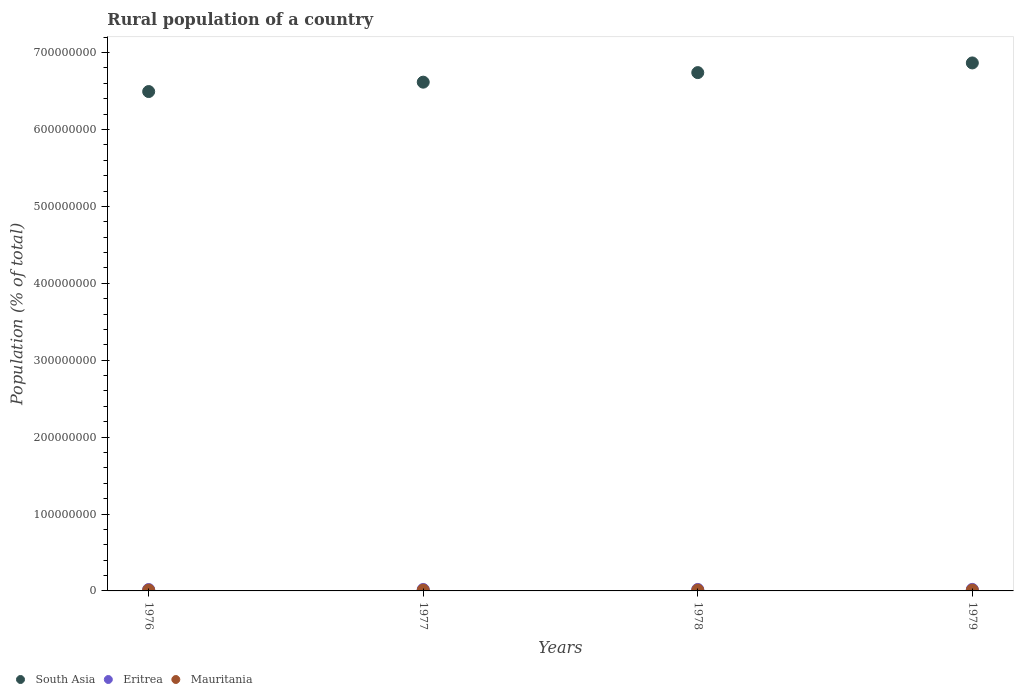How many different coloured dotlines are there?
Offer a terse response. 3. Is the number of dotlines equal to the number of legend labels?
Offer a terse response. Yes. What is the rural population in South Asia in 1976?
Your response must be concise. 6.49e+08. Across all years, what is the maximum rural population in Mauritania?
Give a very brief answer. 1.10e+06. Across all years, what is the minimum rural population in South Asia?
Your answer should be very brief. 6.49e+08. In which year was the rural population in Eritrea maximum?
Your answer should be compact. 1979. In which year was the rural population in Mauritania minimum?
Give a very brief answer. 1976. What is the total rural population in Eritrea in the graph?
Your answer should be compact. 7.65e+06. What is the difference between the rural population in South Asia in 1976 and that in 1978?
Ensure brevity in your answer.  -2.46e+07. What is the difference between the rural population in Mauritania in 1979 and the rural population in Eritrea in 1976?
Keep it short and to the point. -7.35e+05. What is the average rural population in Mauritania per year?
Give a very brief answer. 1.09e+06. In the year 1979, what is the difference between the rural population in Mauritania and rural population in South Asia?
Your response must be concise. -6.85e+08. What is the ratio of the rural population in South Asia in 1976 to that in 1978?
Give a very brief answer. 0.96. Is the difference between the rural population in Mauritania in 1976 and 1977 greater than the difference between the rural population in South Asia in 1976 and 1977?
Give a very brief answer. Yes. What is the difference between the highest and the second highest rural population in South Asia?
Provide a succinct answer. 1.26e+07. What is the difference between the highest and the lowest rural population in Mauritania?
Keep it short and to the point. 3.64e+04. Is the sum of the rural population in Eritrea in 1977 and 1979 greater than the maximum rural population in Mauritania across all years?
Your response must be concise. Yes. Is it the case that in every year, the sum of the rural population in Eritrea and rural population in South Asia  is greater than the rural population in Mauritania?
Offer a very short reply. Yes. Does the rural population in Eritrea monotonically increase over the years?
Provide a succinct answer. Yes. Is the rural population in Mauritania strictly less than the rural population in Eritrea over the years?
Ensure brevity in your answer.  Yes. How many dotlines are there?
Provide a succinct answer. 3. Are the values on the major ticks of Y-axis written in scientific E-notation?
Give a very brief answer. No. Where does the legend appear in the graph?
Your answer should be compact. Bottom left. How many legend labels are there?
Make the answer very short. 3. How are the legend labels stacked?
Your answer should be very brief. Horizontal. What is the title of the graph?
Make the answer very short. Rural population of a country. What is the label or title of the Y-axis?
Provide a succinct answer. Population (% of total). What is the Population (% of total) of South Asia in 1976?
Your response must be concise. 6.49e+08. What is the Population (% of total) of Eritrea in 1976?
Ensure brevity in your answer.  1.84e+06. What is the Population (% of total) in Mauritania in 1976?
Provide a succinct answer. 1.07e+06. What is the Population (% of total) in South Asia in 1977?
Give a very brief answer. 6.62e+08. What is the Population (% of total) in Eritrea in 1977?
Your answer should be compact. 1.89e+06. What is the Population (% of total) of Mauritania in 1977?
Give a very brief answer. 1.08e+06. What is the Population (% of total) of South Asia in 1978?
Keep it short and to the point. 6.74e+08. What is the Population (% of total) in Eritrea in 1978?
Make the answer very short. 1.94e+06. What is the Population (% of total) of Mauritania in 1978?
Your response must be concise. 1.09e+06. What is the Population (% of total) of South Asia in 1979?
Make the answer very short. 6.87e+08. What is the Population (% of total) of Eritrea in 1979?
Ensure brevity in your answer.  1.99e+06. What is the Population (% of total) of Mauritania in 1979?
Offer a very short reply. 1.10e+06. Across all years, what is the maximum Population (% of total) in South Asia?
Your answer should be very brief. 6.87e+08. Across all years, what is the maximum Population (% of total) in Eritrea?
Give a very brief answer. 1.99e+06. Across all years, what is the maximum Population (% of total) in Mauritania?
Make the answer very short. 1.10e+06. Across all years, what is the minimum Population (% of total) in South Asia?
Provide a succinct answer. 6.49e+08. Across all years, what is the minimum Population (% of total) of Eritrea?
Your response must be concise. 1.84e+06. Across all years, what is the minimum Population (% of total) of Mauritania?
Give a very brief answer. 1.07e+06. What is the total Population (% of total) in South Asia in the graph?
Keep it short and to the point. 2.67e+09. What is the total Population (% of total) in Eritrea in the graph?
Offer a terse response. 7.65e+06. What is the total Population (% of total) of Mauritania in the graph?
Your response must be concise. 4.34e+06. What is the difference between the Population (% of total) in South Asia in 1976 and that in 1977?
Keep it short and to the point. -1.22e+07. What is the difference between the Population (% of total) of Eritrea in 1976 and that in 1977?
Your response must be concise. -4.81e+04. What is the difference between the Population (% of total) of Mauritania in 1976 and that in 1977?
Provide a short and direct response. -1.21e+04. What is the difference between the Population (% of total) in South Asia in 1976 and that in 1978?
Give a very brief answer. -2.46e+07. What is the difference between the Population (% of total) of Eritrea in 1976 and that in 1978?
Your answer should be compact. -9.77e+04. What is the difference between the Population (% of total) in Mauritania in 1976 and that in 1978?
Provide a succinct answer. -2.47e+04. What is the difference between the Population (% of total) of South Asia in 1976 and that in 1979?
Offer a terse response. -3.72e+07. What is the difference between the Population (% of total) of Eritrea in 1976 and that in 1979?
Keep it short and to the point. -1.49e+05. What is the difference between the Population (% of total) of Mauritania in 1976 and that in 1979?
Your answer should be very brief. -3.64e+04. What is the difference between the Population (% of total) in South Asia in 1977 and that in 1978?
Keep it short and to the point. -1.24e+07. What is the difference between the Population (% of total) in Eritrea in 1977 and that in 1978?
Offer a terse response. -4.96e+04. What is the difference between the Population (% of total) of Mauritania in 1977 and that in 1978?
Make the answer very short. -1.26e+04. What is the difference between the Population (% of total) of South Asia in 1977 and that in 1979?
Keep it short and to the point. -2.50e+07. What is the difference between the Population (% of total) of Eritrea in 1977 and that in 1979?
Provide a succinct answer. -1.01e+05. What is the difference between the Population (% of total) of Mauritania in 1977 and that in 1979?
Keep it short and to the point. -2.43e+04. What is the difference between the Population (% of total) of South Asia in 1978 and that in 1979?
Ensure brevity in your answer.  -1.26e+07. What is the difference between the Population (% of total) of Eritrea in 1978 and that in 1979?
Offer a terse response. -5.16e+04. What is the difference between the Population (% of total) in Mauritania in 1978 and that in 1979?
Your answer should be compact. -1.17e+04. What is the difference between the Population (% of total) of South Asia in 1976 and the Population (% of total) of Eritrea in 1977?
Your response must be concise. 6.47e+08. What is the difference between the Population (% of total) in South Asia in 1976 and the Population (% of total) in Mauritania in 1977?
Make the answer very short. 6.48e+08. What is the difference between the Population (% of total) of Eritrea in 1976 and the Population (% of total) of Mauritania in 1977?
Ensure brevity in your answer.  7.59e+05. What is the difference between the Population (% of total) in South Asia in 1976 and the Population (% of total) in Eritrea in 1978?
Provide a short and direct response. 6.47e+08. What is the difference between the Population (% of total) of South Asia in 1976 and the Population (% of total) of Mauritania in 1978?
Make the answer very short. 6.48e+08. What is the difference between the Population (% of total) of Eritrea in 1976 and the Population (% of total) of Mauritania in 1978?
Provide a short and direct response. 7.47e+05. What is the difference between the Population (% of total) of South Asia in 1976 and the Population (% of total) of Eritrea in 1979?
Make the answer very short. 6.47e+08. What is the difference between the Population (% of total) of South Asia in 1976 and the Population (% of total) of Mauritania in 1979?
Your answer should be compact. 6.48e+08. What is the difference between the Population (% of total) in Eritrea in 1976 and the Population (% of total) in Mauritania in 1979?
Keep it short and to the point. 7.35e+05. What is the difference between the Population (% of total) in South Asia in 1977 and the Population (% of total) in Eritrea in 1978?
Offer a terse response. 6.60e+08. What is the difference between the Population (% of total) of South Asia in 1977 and the Population (% of total) of Mauritania in 1978?
Your response must be concise. 6.60e+08. What is the difference between the Population (% of total) in Eritrea in 1977 and the Population (% of total) in Mauritania in 1978?
Offer a terse response. 7.95e+05. What is the difference between the Population (% of total) in South Asia in 1977 and the Population (% of total) in Eritrea in 1979?
Offer a terse response. 6.60e+08. What is the difference between the Population (% of total) in South Asia in 1977 and the Population (% of total) in Mauritania in 1979?
Offer a terse response. 6.60e+08. What is the difference between the Population (% of total) of Eritrea in 1977 and the Population (% of total) of Mauritania in 1979?
Ensure brevity in your answer.  7.83e+05. What is the difference between the Population (% of total) of South Asia in 1978 and the Population (% of total) of Eritrea in 1979?
Keep it short and to the point. 6.72e+08. What is the difference between the Population (% of total) in South Asia in 1978 and the Population (% of total) in Mauritania in 1979?
Ensure brevity in your answer.  6.73e+08. What is the difference between the Population (% of total) in Eritrea in 1978 and the Population (% of total) in Mauritania in 1979?
Your response must be concise. 8.33e+05. What is the average Population (% of total) in South Asia per year?
Offer a very short reply. 6.68e+08. What is the average Population (% of total) in Eritrea per year?
Your answer should be very brief. 1.91e+06. What is the average Population (% of total) of Mauritania per year?
Your answer should be compact. 1.09e+06. In the year 1976, what is the difference between the Population (% of total) of South Asia and Population (% of total) of Eritrea?
Your answer should be very brief. 6.47e+08. In the year 1976, what is the difference between the Population (% of total) of South Asia and Population (% of total) of Mauritania?
Your answer should be compact. 6.48e+08. In the year 1976, what is the difference between the Population (% of total) of Eritrea and Population (% of total) of Mauritania?
Keep it short and to the point. 7.71e+05. In the year 1977, what is the difference between the Population (% of total) of South Asia and Population (% of total) of Eritrea?
Your answer should be very brief. 6.60e+08. In the year 1977, what is the difference between the Population (% of total) of South Asia and Population (% of total) of Mauritania?
Ensure brevity in your answer.  6.60e+08. In the year 1977, what is the difference between the Population (% of total) of Eritrea and Population (% of total) of Mauritania?
Offer a very short reply. 8.07e+05. In the year 1978, what is the difference between the Population (% of total) of South Asia and Population (% of total) of Eritrea?
Your response must be concise. 6.72e+08. In the year 1978, what is the difference between the Population (% of total) in South Asia and Population (% of total) in Mauritania?
Make the answer very short. 6.73e+08. In the year 1978, what is the difference between the Population (% of total) of Eritrea and Population (% of total) of Mauritania?
Ensure brevity in your answer.  8.44e+05. In the year 1979, what is the difference between the Population (% of total) in South Asia and Population (% of total) in Eritrea?
Give a very brief answer. 6.85e+08. In the year 1979, what is the difference between the Population (% of total) of South Asia and Population (% of total) of Mauritania?
Give a very brief answer. 6.85e+08. In the year 1979, what is the difference between the Population (% of total) in Eritrea and Population (% of total) in Mauritania?
Keep it short and to the point. 8.84e+05. What is the ratio of the Population (% of total) in South Asia in 1976 to that in 1977?
Make the answer very short. 0.98. What is the ratio of the Population (% of total) of Eritrea in 1976 to that in 1977?
Your answer should be compact. 0.97. What is the ratio of the Population (% of total) in Mauritania in 1976 to that in 1977?
Give a very brief answer. 0.99. What is the ratio of the Population (% of total) of South Asia in 1976 to that in 1978?
Ensure brevity in your answer.  0.96. What is the ratio of the Population (% of total) of Eritrea in 1976 to that in 1978?
Your response must be concise. 0.95. What is the ratio of the Population (% of total) of Mauritania in 1976 to that in 1978?
Provide a short and direct response. 0.98. What is the ratio of the Population (% of total) in South Asia in 1976 to that in 1979?
Your answer should be very brief. 0.95. What is the ratio of the Population (% of total) in Eritrea in 1976 to that in 1979?
Make the answer very short. 0.92. What is the ratio of the Population (% of total) of Mauritania in 1976 to that in 1979?
Your answer should be very brief. 0.97. What is the ratio of the Population (% of total) of South Asia in 1977 to that in 1978?
Your response must be concise. 0.98. What is the ratio of the Population (% of total) of Eritrea in 1977 to that in 1978?
Provide a succinct answer. 0.97. What is the ratio of the Population (% of total) in Mauritania in 1977 to that in 1978?
Your answer should be very brief. 0.99. What is the ratio of the Population (% of total) of South Asia in 1977 to that in 1979?
Offer a terse response. 0.96. What is the ratio of the Population (% of total) of Eritrea in 1977 to that in 1979?
Provide a succinct answer. 0.95. What is the ratio of the Population (% of total) in South Asia in 1978 to that in 1979?
Give a very brief answer. 0.98. What is the ratio of the Population (% of total) of Eritrea in 1978 to that in 1979?
Provide a short and direct response. 0.97. What is the ratio of the Population (% of total) in Mauritania in 1978 to that in 1979?
Your answer should be compact. 0.99. What is the difference between the highest and the second highest Population (% of total) of South Asia?
Your answer should be very brief. 1.26e+07. What is the difference between the highest and the second highest Population (% of total) in Eritrea?
Provide a short and direct response. 5.16e+04. What is the difference between the highest and the second highest Population (% of total) of Mauritania?
Keep it short and to the point. 1.17e+04. What is the difference between the highest and the lowest Population (% of total) of South Asia?
Offer a very short reply. 3.72e+07. What is the difference between the highest and the lowest Population (% of total) of Eritrea?
Your answer should be compact. 1.49e+05. What is the difference between the highest and the lowest Population (% of total) in Mauritania?
Ensure brevity in your answer.  3.64e+04. 